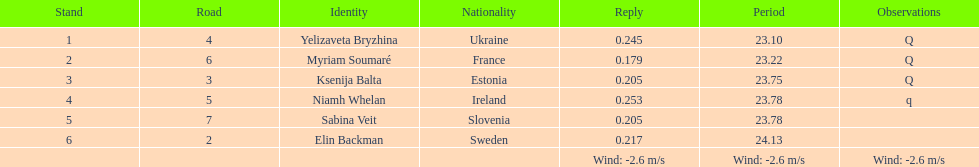Which player is from ireland? Niamh Whelan. 